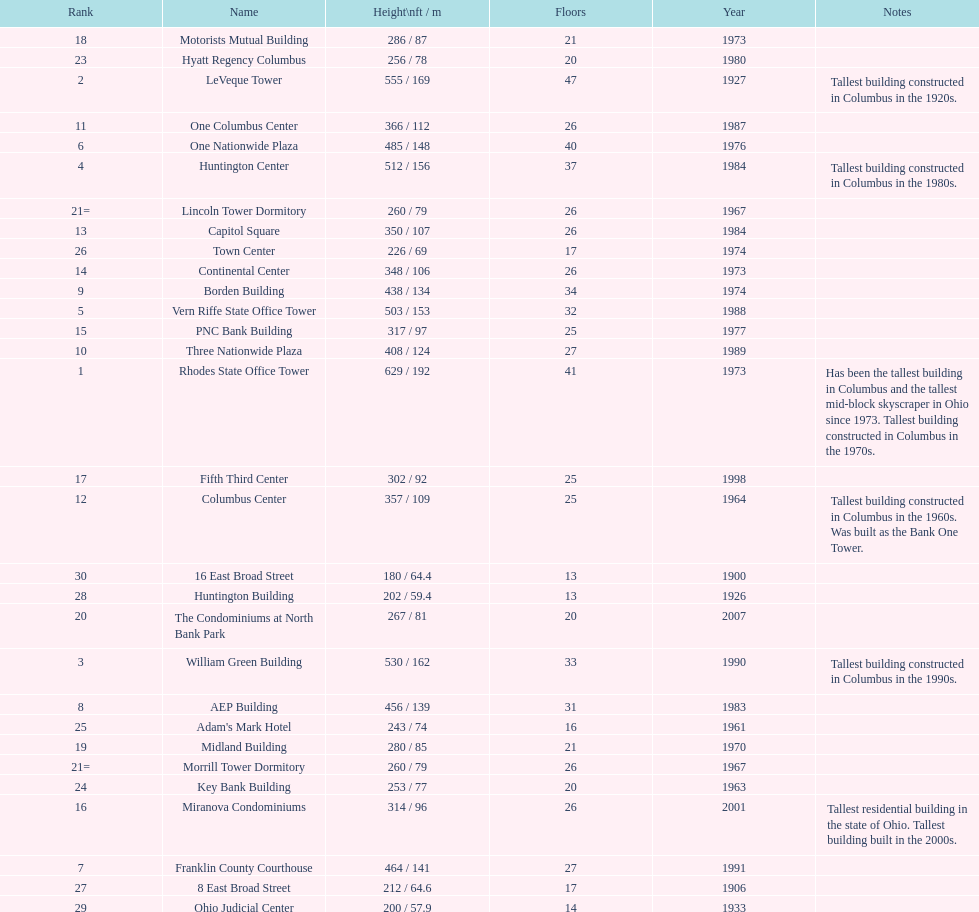What is the number of buildings under 200 ft? 1. 